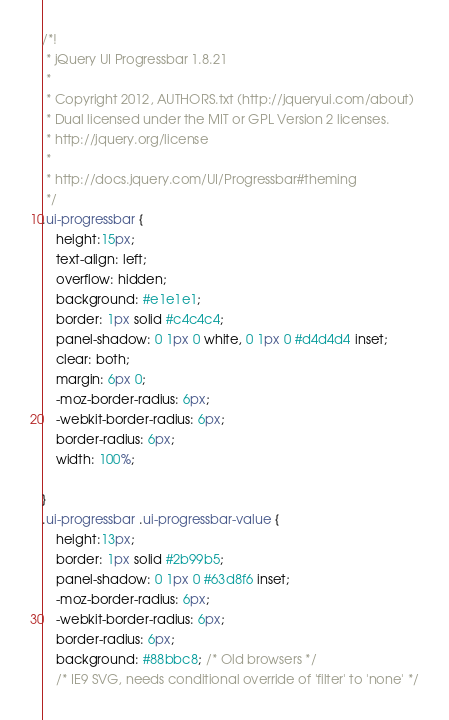Convert code to text. <code><loc_0><loc_0><loc_500><loc_500><_CSS_>/*!
 * jQuery UI Progressbar 1.8.21
 *
 * Copyright 2012, AUTHORS.txt (http://jqueryui.com/about)
 * Dual licensed under the MIT or GPL Version 2 licenses.
 * http://jquery.org/license
 *
 * http://docs.jquery.com/UI/Progressbar#theming
 */
.ui-progressbar { 
	height:15px; 
	text-align: left; 
	overflow: hidden; 
	background: #e1e1e1;
	border: 1px solid #c4c4c4;
	panel-shadow: 0 1px 0 white, 0 1px 0 #d4d4d4 inset;
	clear: both;
	margin: 6px 0;
	-moz-border-radius: 6px;
	-webkit-border-radius: 6px;
	border-radius: 6px;
	width: 100%;
	
}
.ui-progressbar .ui-progressbar-value {
	height:13px; 
	border: 1px solid #2b99b5;
	panel-shadow: 0 1px 0 #63d8f6 inset;
	-moz-border-radius: 6px;
	-webkit-border-radius: 6px;
	border-radius: 6px;
	background: #88bbc8; /* Old browsers */
	/* IE9 SVG, needs conditional override of 'filter' to 'none' */</code> 